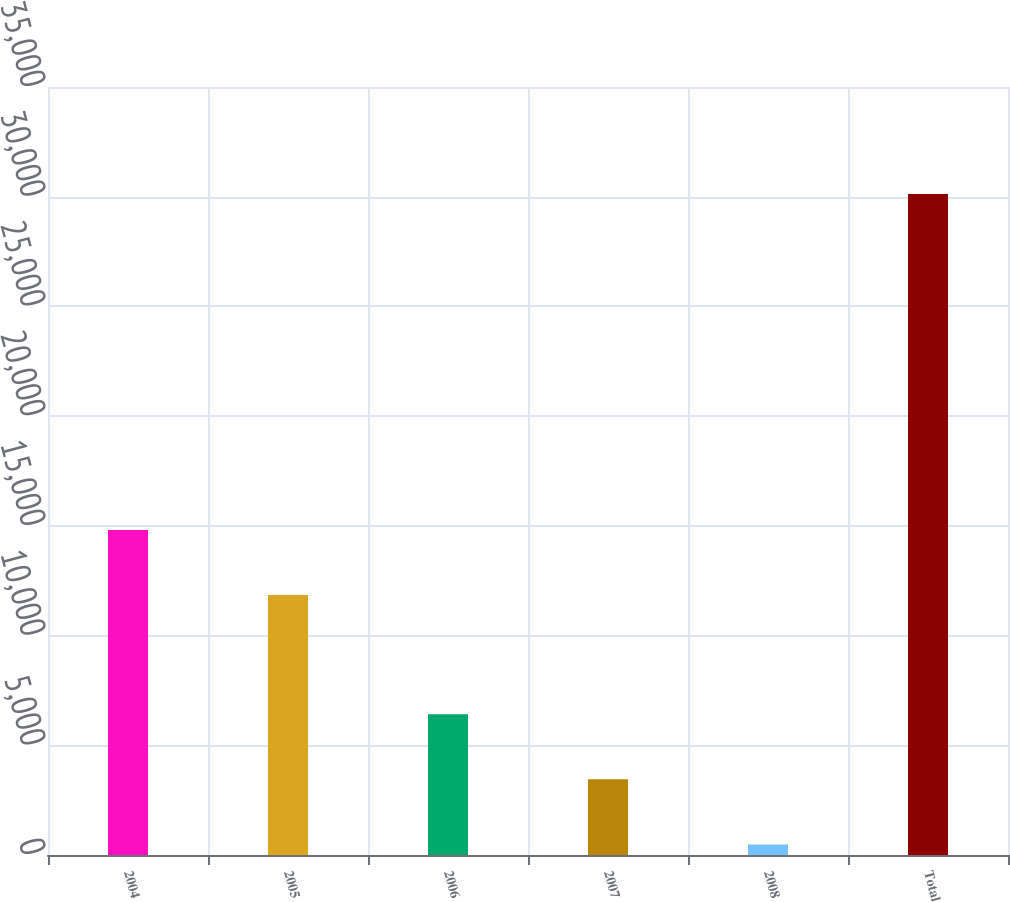Convert chart. <chart><loc_0><loc_0><loc_500><loc_500><bar_chart><fcel>2004<fcel>2005<fcel>2006<fcel>2007<fcel>2008<fcel>Total<nl><fcel>14813.2<fcel>11849<fcel>6411.4<fcel>3447.2<fcel>483<fcel>30125<nl></chart> 